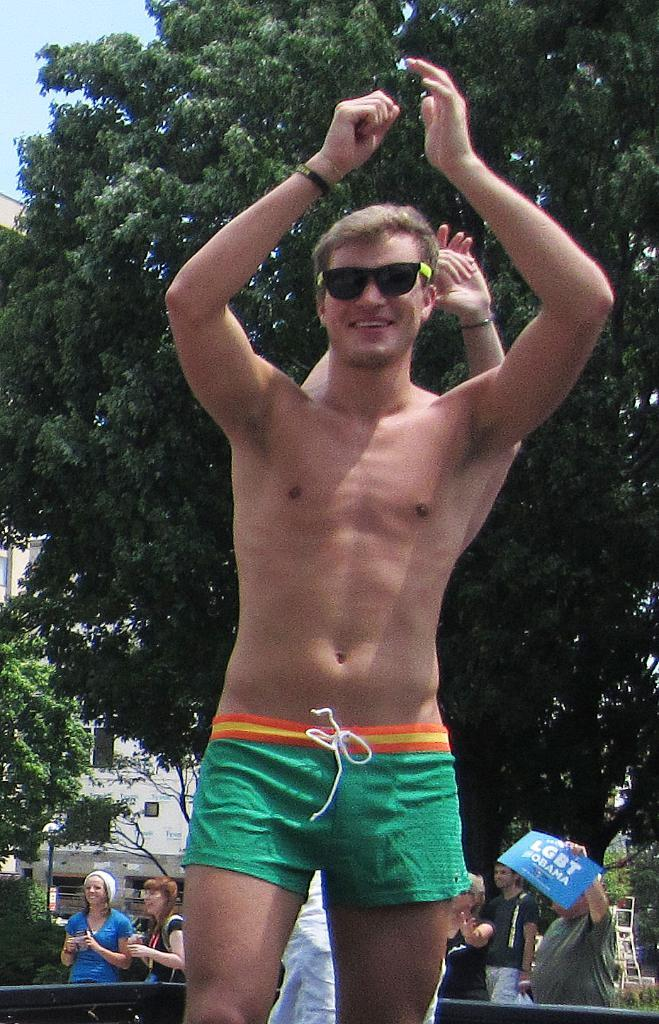What can be seen in the image? There are people standing in the image. What is visible in the background of the image? There are trees, a building, and the sky visible in the background of the image. Can you describe the unspecified objects in the background? Unfortunately, the provided facts do not specify the nature of the unspecified objects in the background. How many ants are crawling on the calendar in the image? There is no calendar or ants present in the image. 